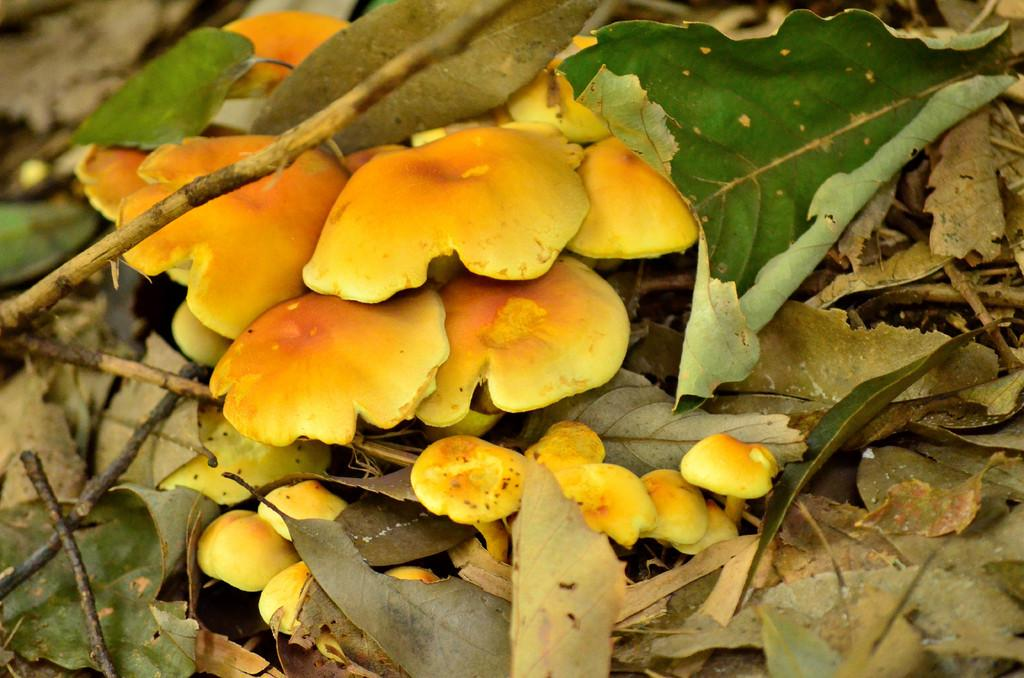What type of fungi can be seen on the ground in the image? There are mushrooms on the ground in the image. What colors are the mushrooms in the image? The mushrooms are white and brown in color. What else can be found on the ground in the image? Leaves are present in the image. How does the image demonstrate an example of comfort? The image does not demonstrate an example of comfort, as it features mushrooms and leaves on the ground. What emotion is being expressed by the mushrooms in the image? The mushrooms in the image do not express any emotions, as they are inanimate objects. 